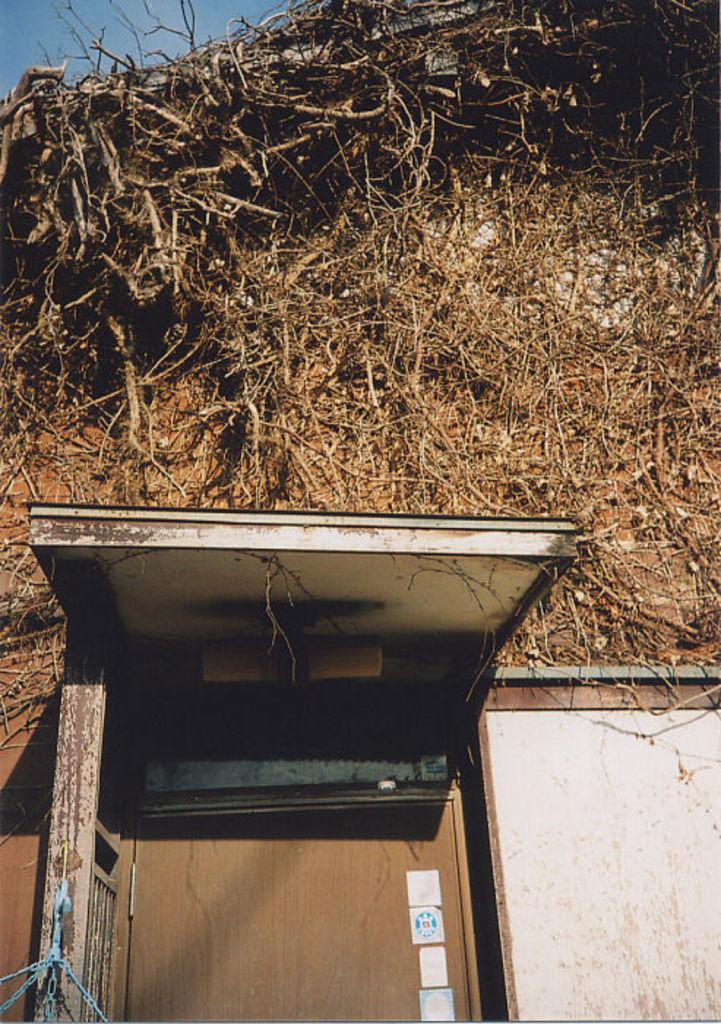What type of structure is present in the image? There is a house in the image. What is a feature of the house that can be seen? The house has a door. Are there any unique characteristics of the house's exterior? Yes, there are roots on the wall of the house. What part of the natural environment is visible in the image? The sky is visible in the top left corner of the image. How many pizzas are stacked on top of the house in the image? There are no pizzas present in the image; the house has roots on the wall instead. 